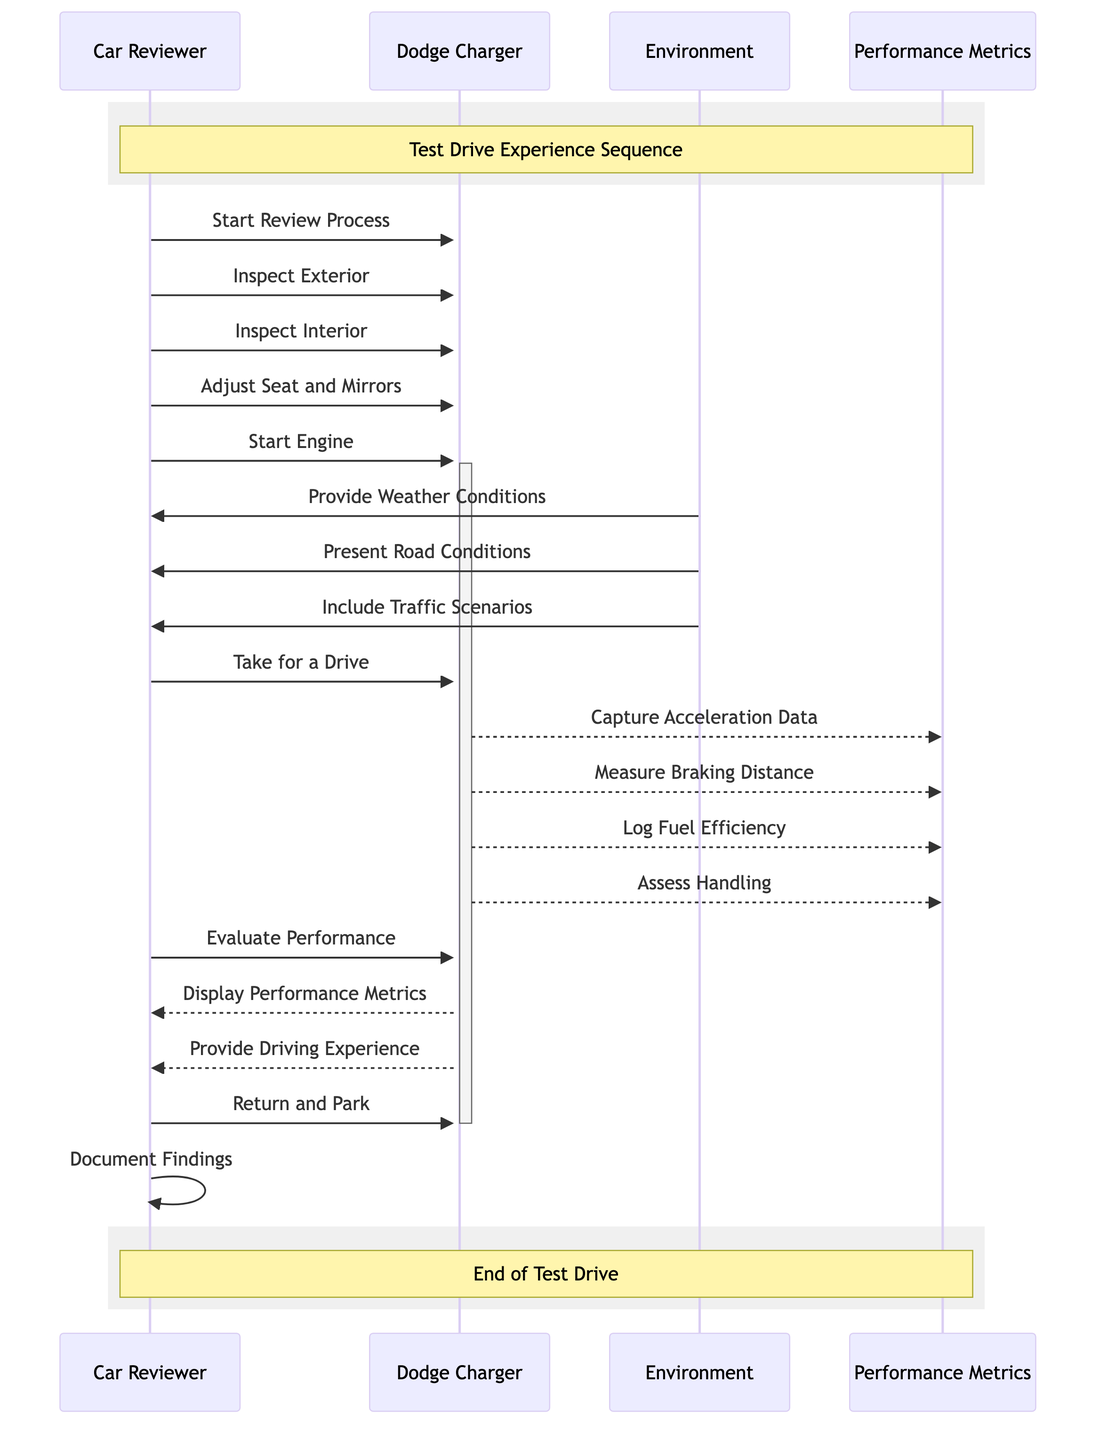How many actions does the Car Reviewer perform? The Car Reviewer performs a total of 9 actions as listed in the diagram. This includes actions like starting the review process, inspecting exterior and interior, adjusting seats and mirrors, and so on.
Answer: 9 What is the first action that the Car Reviewer takes? According to the sequence diagram, the first action taken by the Car Reviewer is to start the review process, which is the initial step in the sequence.
Answer: Start Review Process Which participant provides the weather conditions? The Environment participant provides the weather conditions to the Car Reviewer during the sequence, as indicated in the interactions.
Answer: Environment What performance metric is captured related to acceleration? The performance metric related to acceleration is captured when the Dodge Charger sends acceleration data to the Performance Metrics participant. This is detailed in the sequence where the Dodge Charger communicates with Performance Metrics.
Answer: Capture Acceleration Data How many distinct entities are involved in the sequence diagram? There are four distinct entities involved in the sequence diagram: Car Reviewer, Dodge Charger, Environment, and Performance Metrics. The diagram clearly identifies each participant in the interactions.
Answer: 4 What is the last action performed by the Car Reviewer? The last action performed by the Car Reviewer in the sequence is to document findings, concluding the test drive experience. This is the final step noted in the diagram.
Answer: Document Findings Which participant provides the driving experience to the Car Reviewer? The Dodge Charger provides the driving experience to the Car Reviewer after evaluating performance, as captured in the interaction sequence.
Answer: Dodge Charger What types of road conditions does the Environment present? The Environment presents both road conditions and traffic scenarios, as mentioned in the sequence diagram, where these actions are specified.
Answer: Road Conditions and Traffic Scenarios What is the purpose of the Performance Metrics participant in the test drive sequence? The Performance Metrics participant serves to log various measurements such as acceleration data, braking distance, fuel efficiency, and handling assessments during the test drive. This shows the comprehensive evaluation focus.
Answer: Log Performance Data 